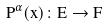<formula> <loc_0><loc_0><loc_500><loc_500>P ^ { \alpha } ( x ) \colon E \rightarrow F</formula> 